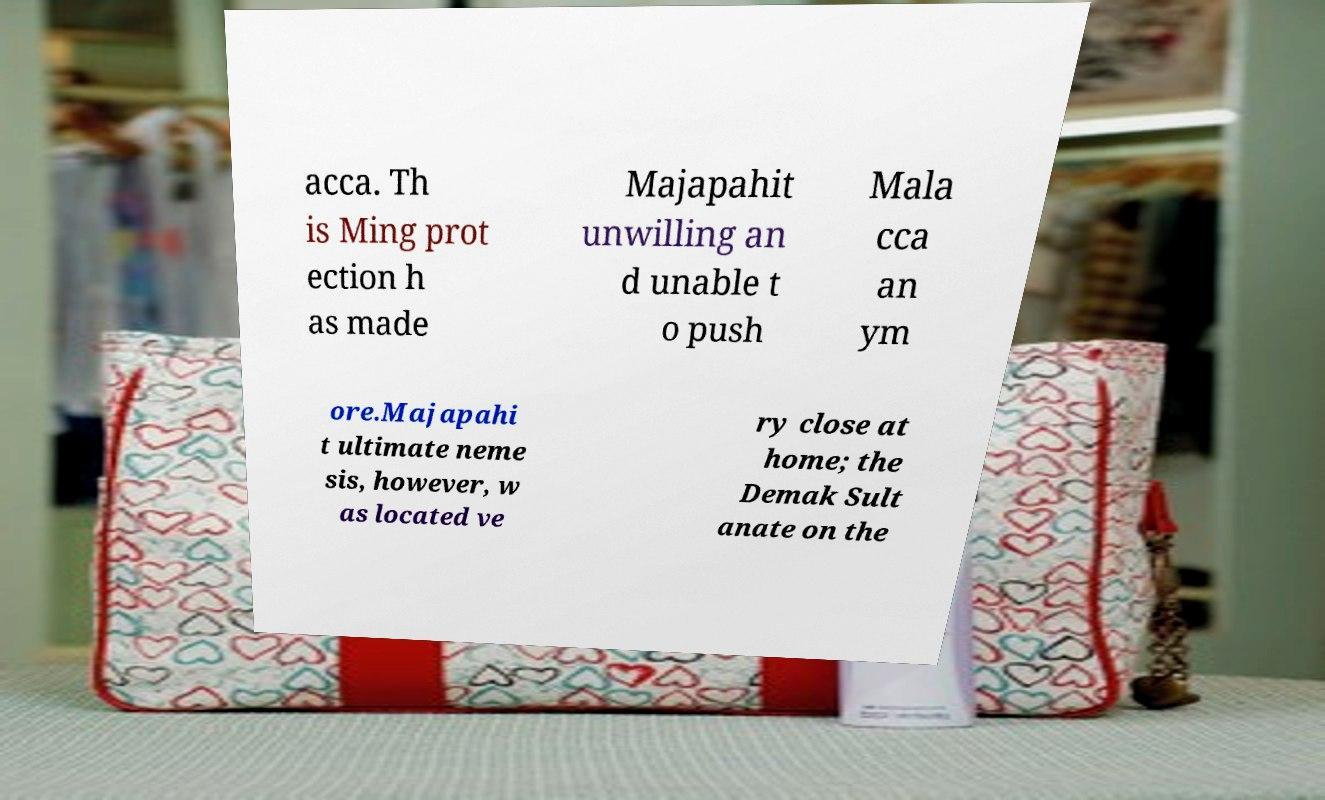Could you assist in decoding the text presented in this image and type it out clearly? acca. Th is Ming prot ection h as made Majapahit unwilling an d unable t o push Mala cca an ym ore.Majapahi t ultimate neme sis, however, w as located ve ry close at home; the Demak Sult anate on the 